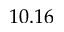<formula> <loc_0><loc_0><loc_500><loc_500>1 0 . 1 6</formula> 